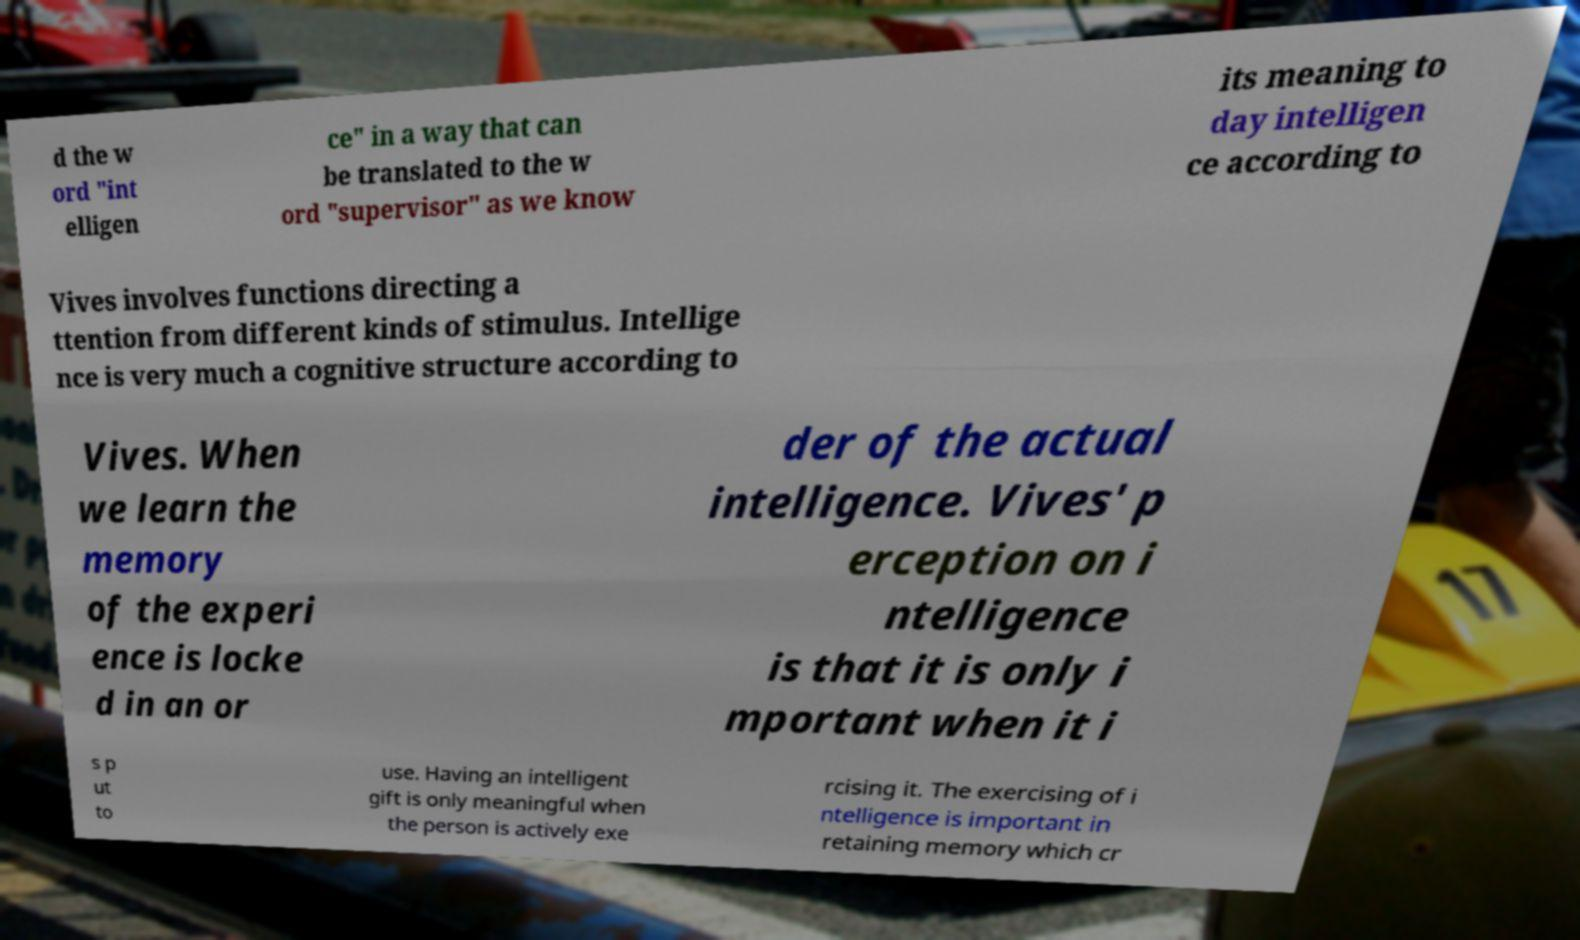For documentation purposes, I need the text within this image transcribed. Could you provide that? d the w ord "int elligen ce" in a way that can be translated to the w ord "supervisor" as we know its meaning to day intelligen ce according to Vives involves functions directing a ttention from different kinds of stimulus. Intellige nce is very much a cognitive structure according to Vives. When we learn the memory of the experi ence is locke d in an or der of the actual intelligence. Vives' p erception on i ntelligence is that it is only i mportant when it i s p ut to use. Having an intelligent gift is only meaningful when the person is actively exe rcising it. The exercising of i ntelligence is important in retaining memory which cr 